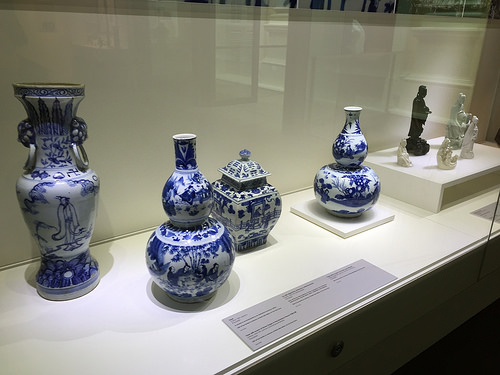<image>
Is the vase on the wooden block? No. The vase is not positioned on the wooden block. They may be near each other, but the vase is not supported by or resting on top of the wooden block. 